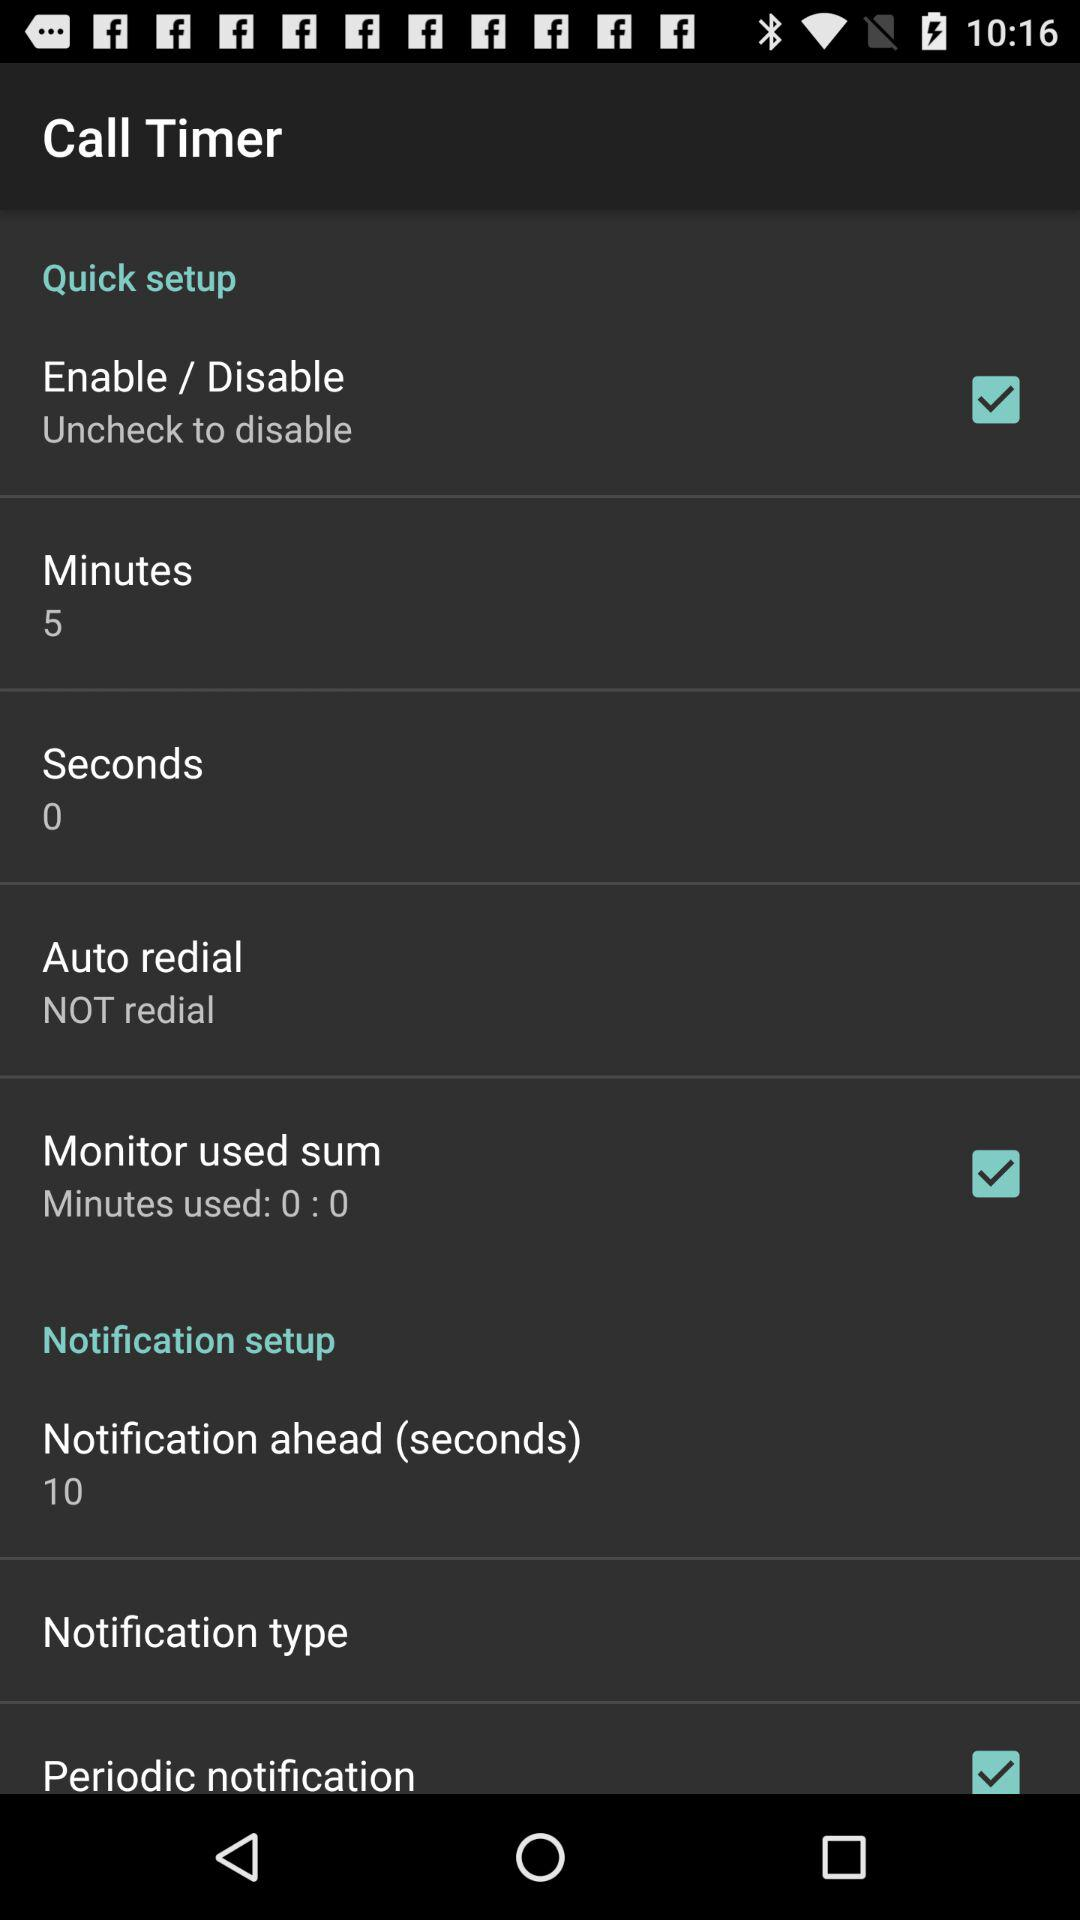Which options are checked? The checked options are "Enable/Disable", "Monitor used sum" and "Periodic notification". 